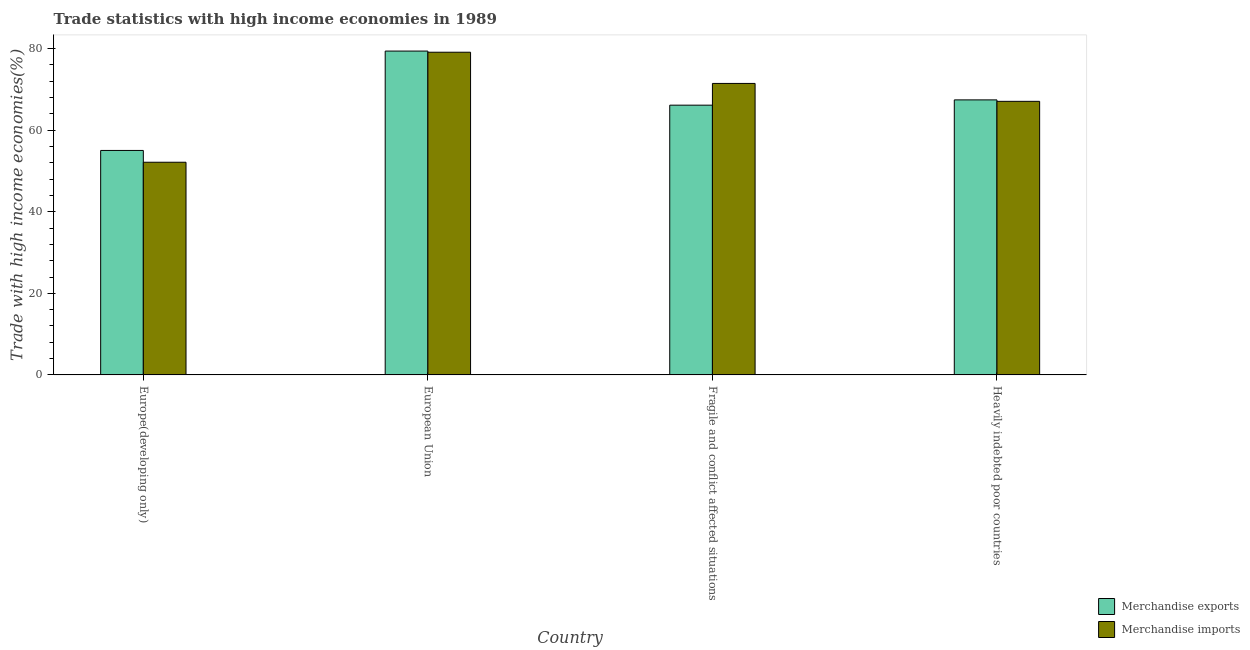How many different coloured bars are there?
Offer a very short reply. 2. How many groups of bars are there?
Ensure brevity in your answer.  4. Are the number of bars per tick equal to the number of legend labels?
Provide a short and direct response. Yes. What is the label of the 4th group of bars from the left?
Make the answer very short. Heavily indebted poor countries. In how many cases, is the number of bars for a given country not equal to the number of legend labels?
Provide a succinct answer. 0. What is the merchandise exports in Fragile and conflict affected situations?
Provide a short and direct response. 66.14. Across all countries, what is the maximum merchandise exports?
Ensure brevity in your answer.  79.41. Across all countries, what is the minimum merchandise exports?
Give a very brief answer. 55.04. In which country was the merchandise imports minimum?
Make the answer very short. Europe(developing only). What is the total merchandise imports in the graph?
Your answer should be very brief. 269.83. What is the difference between the merchandise exports in Fragile and conflict affected situations and that in Heavily indebted poor countries?
Make the answer very short. -1.29. What is the difference between the merchandise exports in European Union and the merchandise imports in Heavily indebted poor countries?
Your response must be concise. 12.33. What is the average merchandise imports per country?
Provide a short and direct response. 67.46. What is the difference between the merchandise imports and merchandise exports in Europe(developing only)?
Your answer should be compact. -2.89. What is the ratio of the merchandise exports in European Union to that in Fragile and conflict affected situations?
Keep it short and to the point. 1.2. Is the merchandise imports in Europe(developing only) less than that in European Union?
Keep it short and to the point. Yes. What is the difference between the highest and the second highest merchandise imports?
Provide a succinct answer. 7.65. What is the difference between the highest and the lowest merchandise imports?
Ensure brevity in your answer.  26.98. In how many countries, is the merchandise imports greater than the average merchandise imports taken over all countries?
Keep it short and to the point. 2. What does the 2nd bar from the left in Europe(developing only) represents?
Your answer should be compact. Merchandise imports. Are the values on the major ticks of Y-axis written in scientific E-notation?
Provide a succinct answer. No. Where does the legend appear in the graph?
Keep it short and to the point. Bottom right. How many legend labels are there?
Give a very brief answer. 2. What is the title of the graph?
Make the answer very short. Trade statistics with high income economies in 1989. Does "Under-five" appear as one of the legend labels in the graph?
Keep it short and to the point. No. What is the label or title of the X-axis?
Your answer should be very brief. Country. What is the label or title of the Y-axis?
Ensure brevity in your answer.  Trade with high income economies(%). What is the Trade with high income economies(%) in Merchandise exports in Europe(developing only)?
Your answer should be very brief. 55.04. What is the Trade with high income economies(%) in Merchandise imports in Europe(developing only)?
Give a very brief answer. 52.15. What is the Trade with high income economies(%) in Merchandise exports in European Union?
Ensure brevity in your answer.  79.41. What is the Trade with high income economies(%) in Merchandise imports in European Union?
Provide a succinct answer. 79.12. What is the Trade with high income economies(%) of Merchandise exports in Fragile and conflict affected situations?
Keep it short and to the point. 66.14. What is the Trade with high income economies(%) of Merchandise imports in Fragile and conflict affected situations?
Ensure brevity in your answer.  71.47. What is the Trade with high income economies(%) of Merchandise exports in Heavily indebted poor countries?
Provide a succinct answer. 67.44. What is the Trade with high income economies(%) in Merchandise imports in Heavily indebted poor countries?
Your answer should be compact. 67.08. Across all countries, what is the maximum Trade with high income economies(%) in Merchandise exports?
Your answer should be compact. 79.41. Across all countries, what is the maximum Trade with high income economies(%) of Merchandise imports?
Provide a short and direct response. 79.12. Across all countries, what is the minimum Trade with high income economies(%) of Merchandise exports?
Provide a succinct answer. 55.04. Across all countries, what is the minimum Trade with high income economies(%) of Merchandise imports?
Provide a short and direct response. 52.15. What is the total Trade with high income economies(%) of Merchandise exports in the graph?
Provide a succinct answer. 268.03. What is the total Trade with high income economies(%) in Merchandise imports in the graph?
Keep it short and to the point. 269.83. What is the difference between the Trade with high income economies(%) of Merchandise exports in Europe(developing only) and that in European Union?
Offer a terse response. -24.37. What is the difference between the Trade with high income economies(%) in Merchandise imports in Europe(developing only) and that in European Union?
Your answer should be very brief. -26.98. What is the difference between the Trade with high income economies(%) of Merchandise exports in Europe(developing only) and that in Fragile and conflict affected situations?
Provide a succinct answer. -11.11. What is the difference between the Trade with high income economies(%) in Merchandise imports in Europe(developing only) and that in Fragile and conflict affected situations?
Ensure brevity in your answer.  -19.32. What is the difference between the Trade with high income economies(%) of Merchandise exports in Europe(developing only) and that in Heavily indebted poor countries?
Keep it short and to the point. -12.4. What is the difference between the Trade with high income economies(%) in Merchandise imports in Europe(developing only) and that in Heavily indebted poor countries?
Provide a succinct answer. -14.93. What is the difference between the Trade with high income economies(%) of Merchandise exports in European Union and that in Fragile and conflict affected situations?
Make the answer very short. 13.26. What is the difference between the Trade with high income economies(%) in Merchandise imports in European Union and that in Fragile and conflict affected situations?
Your response must be concise. 7.65. What is the difference between the Trade with high income economies(%) in Merchandise exports in European Union and that in Heavily indebted poor countries?
Offer a very short reply. 11.97. What is the difference between the Trade with high income economies(%) of Merchandise imports in European Union and that in Heavily indebted poor countries?
Your response must be concise. 12.04. What is the difference between the Trade with high income economies(%) in Merchandise exports in Fragile and conflict affected situations and that in Heavily indebted poor countries?
Make the answer very short. -1.29. What is the difference between the Trade with high income economies(%) of Merchandise imports in Fragile and conflict affected situations and that in Heavily indebted poor countries?
Keep it short and to the point. 4.39. What is the difference between the Trade with high income economies(%) of Merchandise exports in Europe(developing only) and the Trade with high income economies(%) of Merchandise imports in European Union?
Your response must be concise. -24.09. What is the difference between the Trade with high income economies(%) of Merchandise exports in Europe(developing only) and the Trade with high income economies(%) of Merchandise imports in Fragile and conflict affected situations?
Provide a short and direct response. -16.43. What is the difference between the Trade with high income economies(%) in Merchandise exports in Europe(developing only) and the Trade with high income economies(%) in Merchandise imports in Heavily indebted poor countries?
Provide a short and direct response. -12.04. What is the difference between the Trade with high income economies(%) in Merchandise exports in European Union and the Trade with high income economies(%) in Merchandise imports in Fragile and conflict affected situations?
Your answer should be compact. 7.94. What is the difference between the Trade with high income economies(%) in Merchandise exports in European Union and the Trade with high income economies(%) in Merchandise imports in Heavily indebted poor countries?
Your response must be concise. 12.33. What is the difference between the Trade with high income economies(%) in Merchandise exports in Fragile and conflict affected situations and the Trade with high income economies(%) in Merchandise imports in Heavily indebted poor countries?
Offer a terse response. -0.94. What is the average Trade with high income economies(%) of Merchandise exports per country?
Your answer should be compact. 67.01. What is the average Trade with high income economies(%) of Merchandise imports per country?
Give a very brief answer. 67.46. What is the difference between the Trade with high income economies(%) of Merchandise exports and Trade with high income economies(%) of Merchandise imports in Europe(developing only)?
Your answer should be very brief. 2.89. What is the difference between the Trade with high income economies(%) of Merchandise exports and Trade with high income economies(%) of Merchandise imports in European Union?
Provide a short and direct response. 0.28. What is the difference between the Trade with high income economies(%) in Merchandise exports and Trade with high income economies(%) in Merchandise imports in Fragile and conflict affected situations?
Provide a short and direct response. -5.33. What is the difference between the Trade with high income economies(%) of Merchandise exports and Trade with high income economies(%) of Merchandise imports in Heavily indebted poor countries?
Offer a very short reply. 0.36. What is the ratio of the Trade with high income economies(%) in Merchandise exports in Europe(developing only) to that in European Union?
Your answer should be very brief. 0.69. What is the ratio of the Trade with high income economies(%) of Merchandise imports in Europe(developing only) to that in European Union?
Give a very brief answer. 0.66. What is the ratio of the Trade with high income economies(%) in Merchandise exports in Europe(developing only) to that in Fragile and conflict affected situations?
Make the answer very short. 0.83. What is the ratio of the Trade with high income economies(%) in Merchandise imports in Europe(developing only) to that in Fragile and conflict affected situations?
Keep it short and to the point. 0.73. What is the ratio of the Trade with high income economies(%) of Merchandise exports in Europe(developing only) to that in Heavily indebted poor countries?
Make the answer very short. 0.82. What is the ratio of the Trade with high income economies(%) in Merchandise imports in Europe(developing only) to that in Heavily indebted poor countries?
Ensure brevity in your answer.  0.78. What is the ratio of the Trade with high income economies(%) in Merchandise exports in European Union to that in Fragile and conflict affected situations?
Ensure brevity in your answer.  1.2. What is the ratio of the Trade with high income economies(%) of Merchandise imports in European Union to that in Fragile and conflict affected situations?
Offer a very short reply. 1.11. What is the ratio of the Trade with high income economies(%) in Merchandise exports in European Union to that in Heavily indebted poor countries?
Keep it short and to the point. 1.18. What is the ratio of the Trade with high income economies(%) of Merchandise imports in European Union to that in Heavily indebted poor countries?
Offer a terse response. 1.18. What is the ratio of the Trade with high income economies(%) of Merchandise exports in Fragile and conflict affected situations to that in Heavily indebted poor countries?
Offer a very short reply. 0.98. What is the ratio of the Trade with high income economies(%) of Merchandise imports in Fragile and conflict affected situations to that in Heavily indebted poor countries?
Provide a succinct answer. 1.07. What is the difference between the highest and the second highest Trade with high income economies(%) in Merchandise exports?
Your answer should be compact. 11.97. What is the difference between the highest and the second highest Trade with high income economies(%) of Merchandise imports?
Keep it short and to the point. 7.65. What is the difference between the highest and the lowest Trade with high income economies(%) of Merchandise exports?
Your answer should be compact. 24.37. What is the difference between the highest and the lowest Trade with high income economies(%) in Merchandise imports?
Your response must be concise. 26.98. 